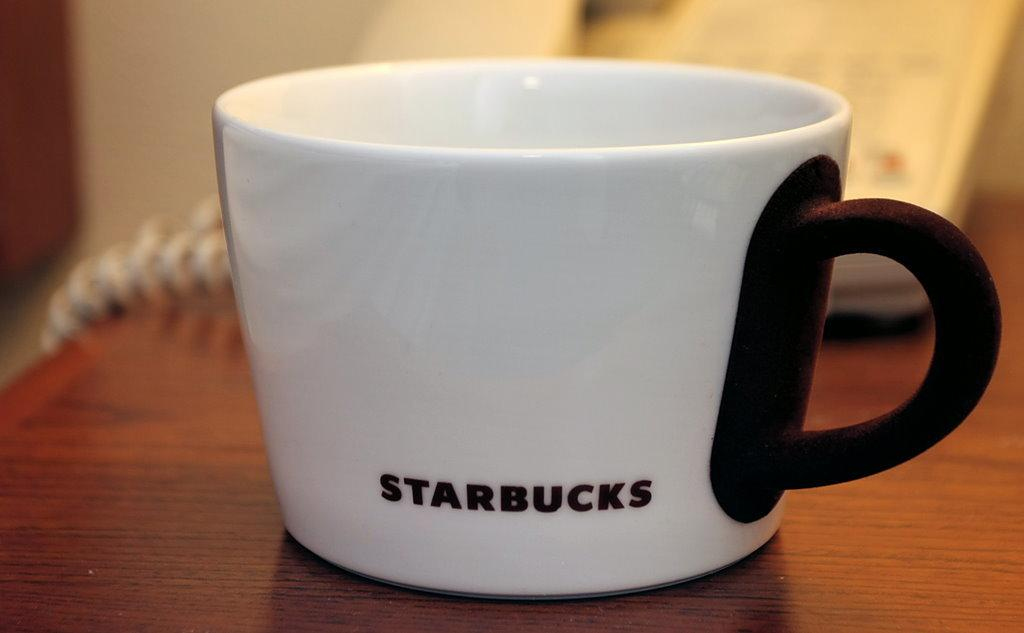<image>
Create a compact narrative representing the image presented. A white coffee mug with a brown handle that reads, "Starbucks". 